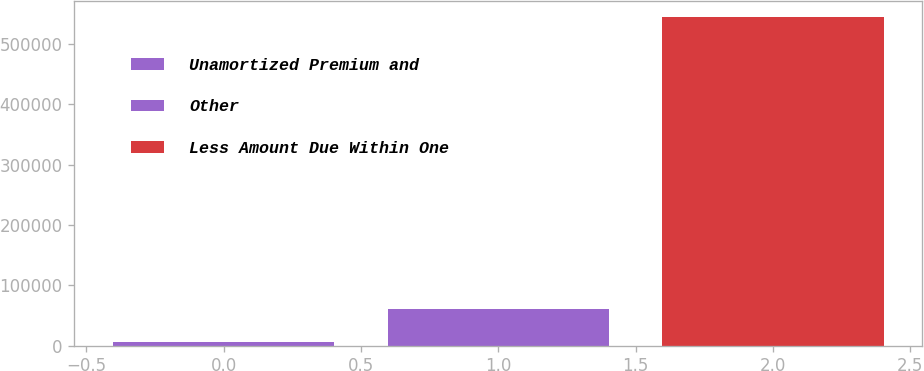Convert chart. <chart><loc_0><loc_0><loc_500><loc_500><bar_chart><fcel>Unamortized Premium and<fcel>Other<fcel>Less Amount Due Within One<nl><fcel>6906<fcel>60661.4<fcel>544460<nl></chart> 